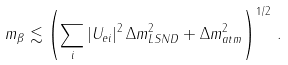Convert formula to latex. <formula><loc_0><loc_0><loc_500><loc_500>m _ { \beta } \lesssim \left ( \sum _ { i } | U _ { e i } | ^ { 2 } \, \Delta { m } ^ { 2 } _ { L S N D } + \Delta { m } ^ { 2 } _ { a t m } \right ) ^ { 1 / 2 } \, .</formula> 